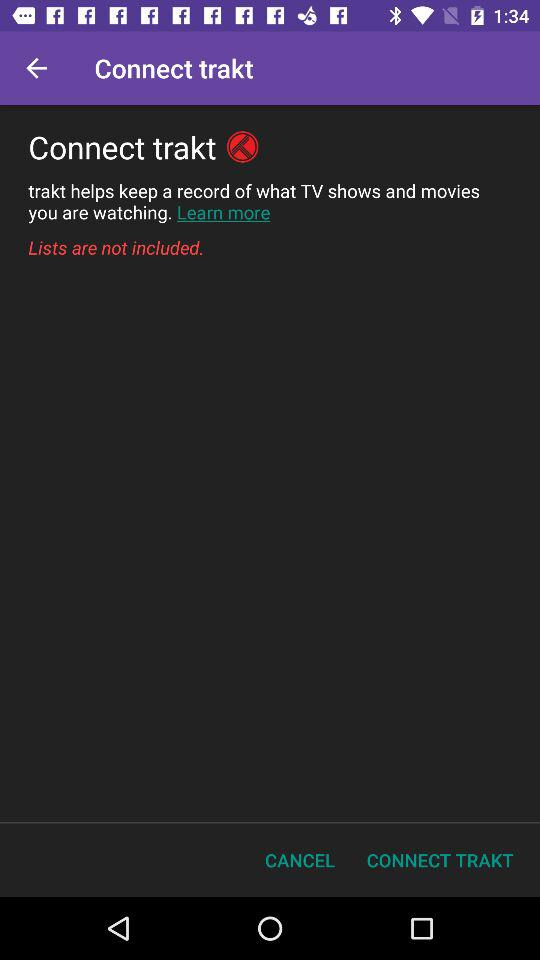What is the application name? The application name is "Connect trakt". 